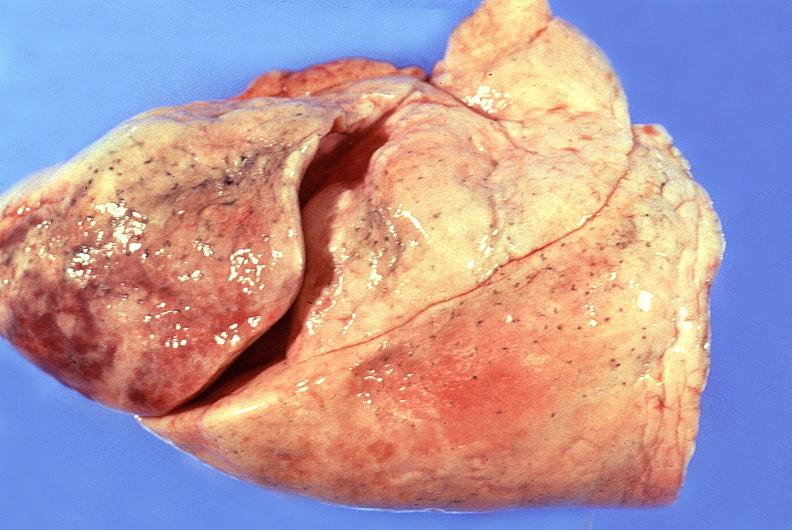where is this?
Answer the question using a single word or phrase. Lung 